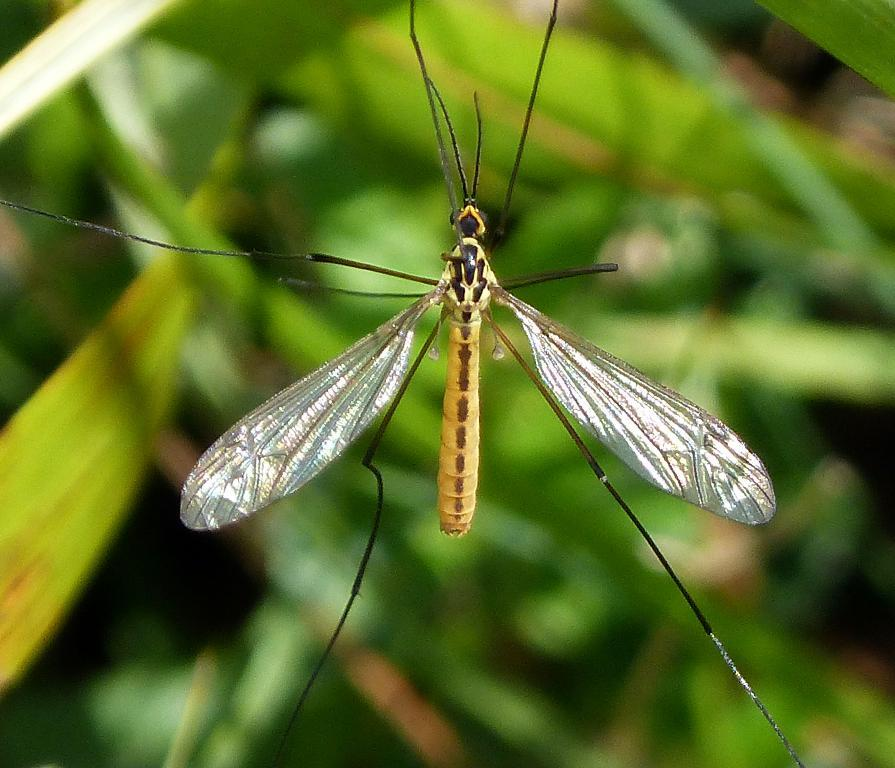What is the main subject in the middle of the image? There is an insect in the middle of the image. What can be seen in the background of the image? There are green leaves in the background of the image. What type of snow can be seen falling in the image? There is no snow present in the image; it features an insect and green leaves in the background. Is there a farmer visible in the image? There is no farmer present in the image. 